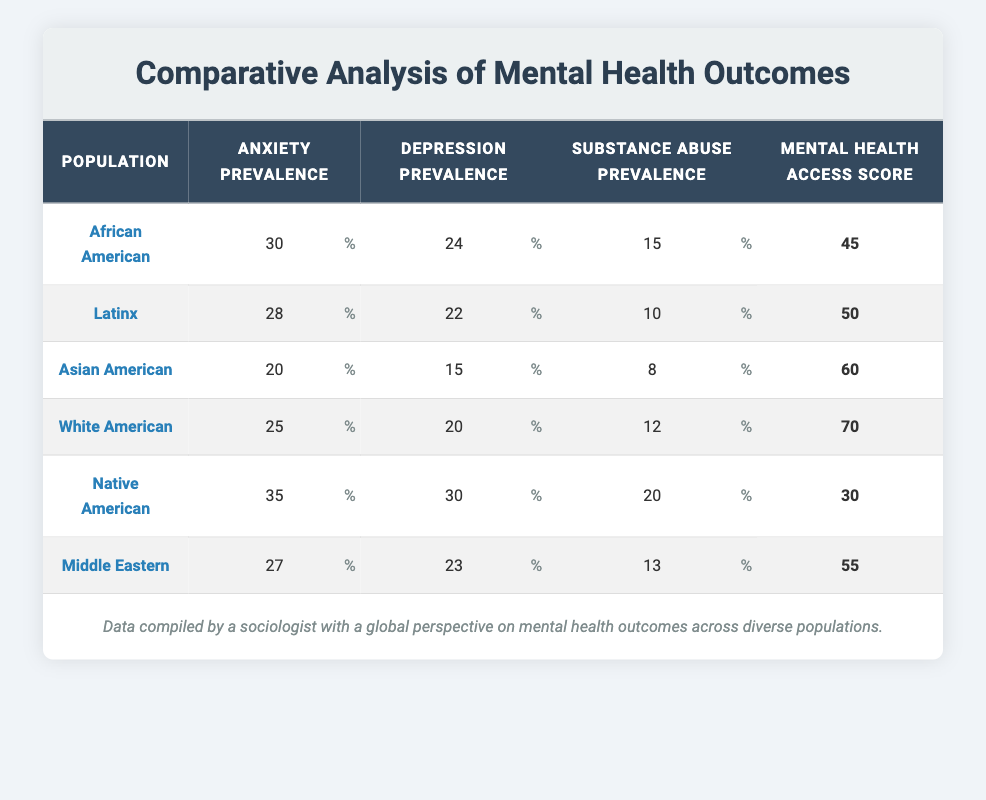What is the anxiety prevalence for Native American populations? The table directly shows that the anxiety prevalence for Native American populations is listed as 35.
Answer: 35 Which population has the highest substance abuse prevalence? Looking at the substance abuse prevalence column, Native Americans have the highest value at 20.
Answer: Native American What is the average depression prevalence across all populations? To find the average, add the values for depression prevalence (24 + 22 + 15 + 20 + 30 + 23 = 134) and divide by the number of populations (6). Therefore, the average is 134/6 = 22.33.
Answer: 22.33 True or False: Asian American populations have a higher mental health access score than Latinx populations. The mental health access score for Asian Americans is 60 while Latinx populations have a score of 50, so it is true.
Answer: True What is the total substance abuse prevalence for the two populations with the highest scores? The two populations with the highest substance abuse prevalence are Native American (20) and African American (15). Adding these together gives us 20 + 15 = 35.
Answer: 35 Which group has the lowest anxiety prevalence score? The table shows that Asian Americans have the lowest anxiety prevalence score at 20.
Answer: Asian American Is the substance abuse prevalence for Latinx higher than for White Americans? The substance abuse prevalence for Latinx is 10, while for White Americans it is 12; thus, it is false that Latinx has a higher prevalence.
Answer: False What is the difference between the mental health access scores for Native American and White American populations? The mental health access score for Native Americans is 30 and for White Americans is 70. The difference is 70 - 30 = 40.
Answer: 40 Which population has both the highest anxiety and depression prevalence scores? Native Americans have the highest anxiety prevalence at 35 and depression prevalence at 30, making them the group with the highest scores in both categories.
Answer: Native American 